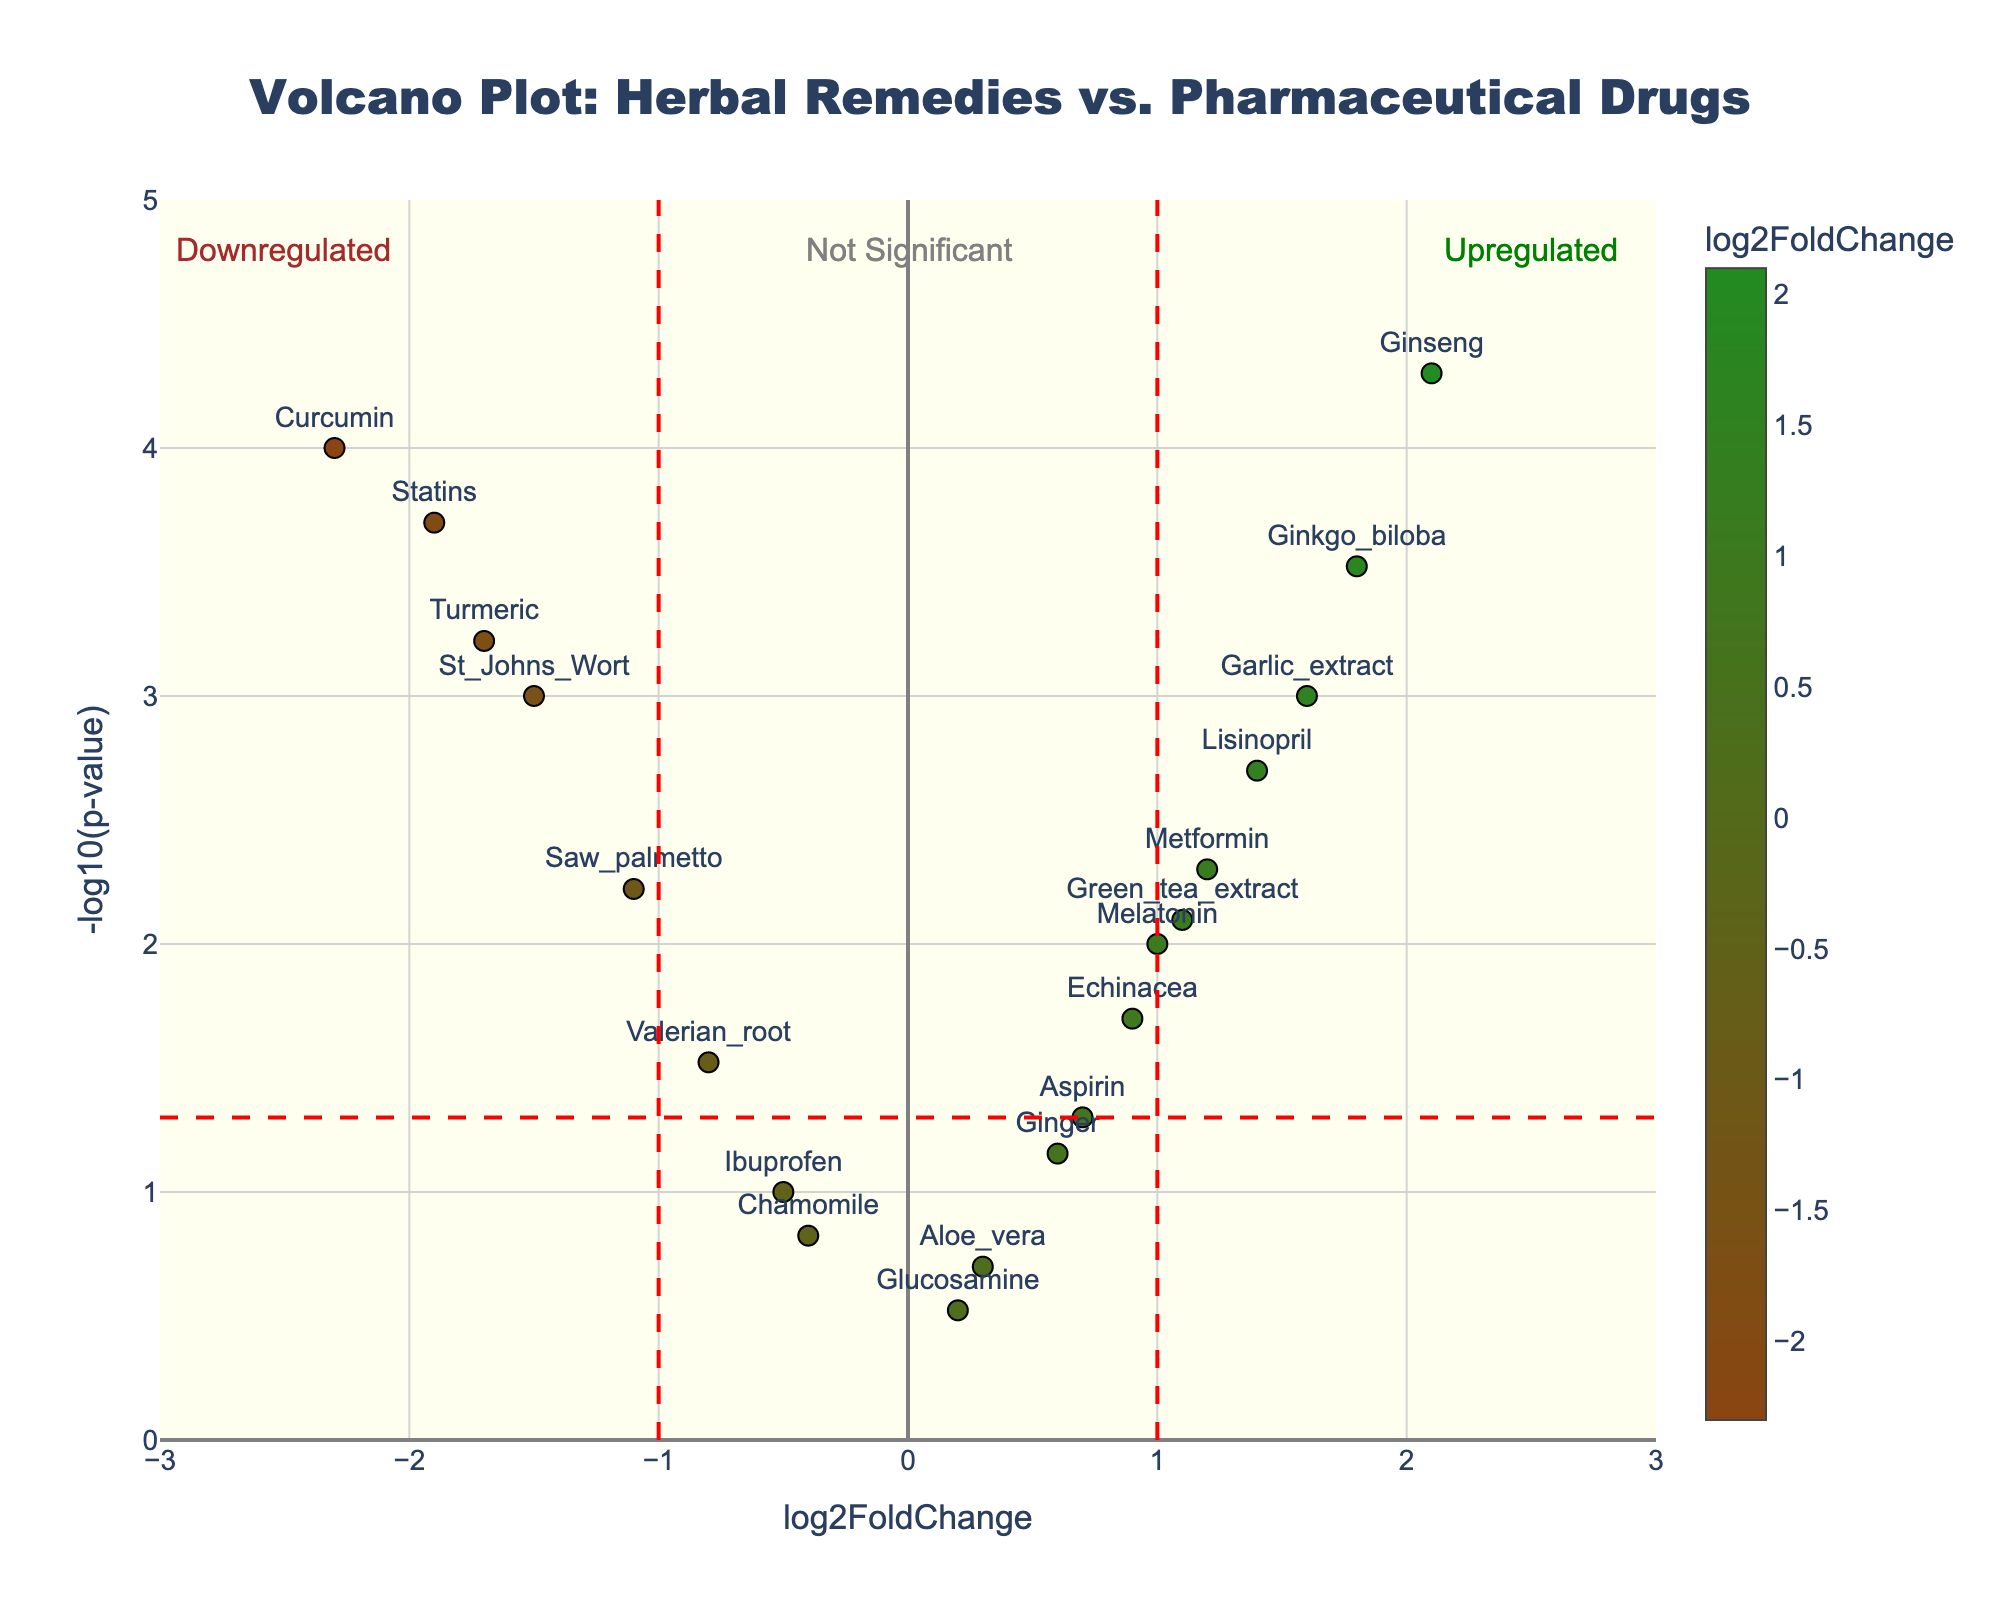What's the title of the plot? Look at the top of the figure, the title is displayed prominently there.
Answer: Volcano Plot: Herbal Remedies vs. Pharmaceutical Drugs What does the x-axis represent? The label at the bottom of the x-axis indicates it represents 'log2FoldChange'.
Answer: log2FoldChange How many data points are plotted? Count the number of markers (points) on the plot.
Answer: 19 Which gene has the highest -log10(p-value)? Identify the data point that is positioned highest on the y-axis.
Answer: Ginseng What are the colors of the significance lines? Look at the dotted lines on the plot, they are marked in a distinct color.
Answer: Red Which pharmaceutical drug shows the highest log2FoldChange? Identify the pharmaceutical drug with the rightmost position on the x-axis.
Answer: Metformin What's the p-value of the Ginkgo biloba gene? Hover over the Ginkgo biloba data point to read its p-value. Convert from -log10(p-value) to p-value if necessary.
Answer: 0.0003 Does Curcumin show upregulation or downregulation? Look at where Curcumin is plotted on the x-axis; downregulation refers to negative log2FoldChange and upregulation to positive log2FoldChange.
Answer: Downregulation Which is more significant, Echinacea or Melatonin? Compare their y-axis values (-log10(p-value)); the higher the value, the more significant the data point.
Answer: Melatonin Which gene has the least significant p-value? Identify the data point closest to the x-axis (lowest on the y-axis).
Answer: Glucosamine 